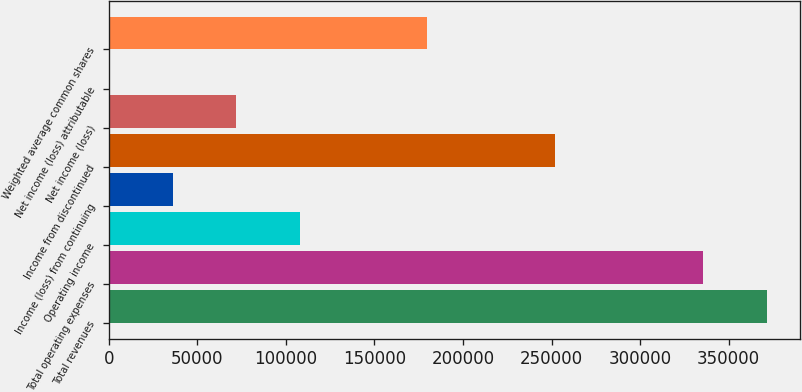<chart> <loc_0><loc_0><loc_500><loc_500><bar_chart><fcel>Total revenues<fcel>Total operating expenses<fcel>Operating income<fcel>Income (loss) from continuing<fcel>Income from discontinued<fcel>Net income (loss)<fcel>Net income (loss) attributable<fcel>Weighted average common shares<nl><fcel>371591<fcel>335634<fcel>107871<fcel>35957.1<fcel>251699<fcel>71914.1<fcel>0.05<fcel>179785<nl></chart> 